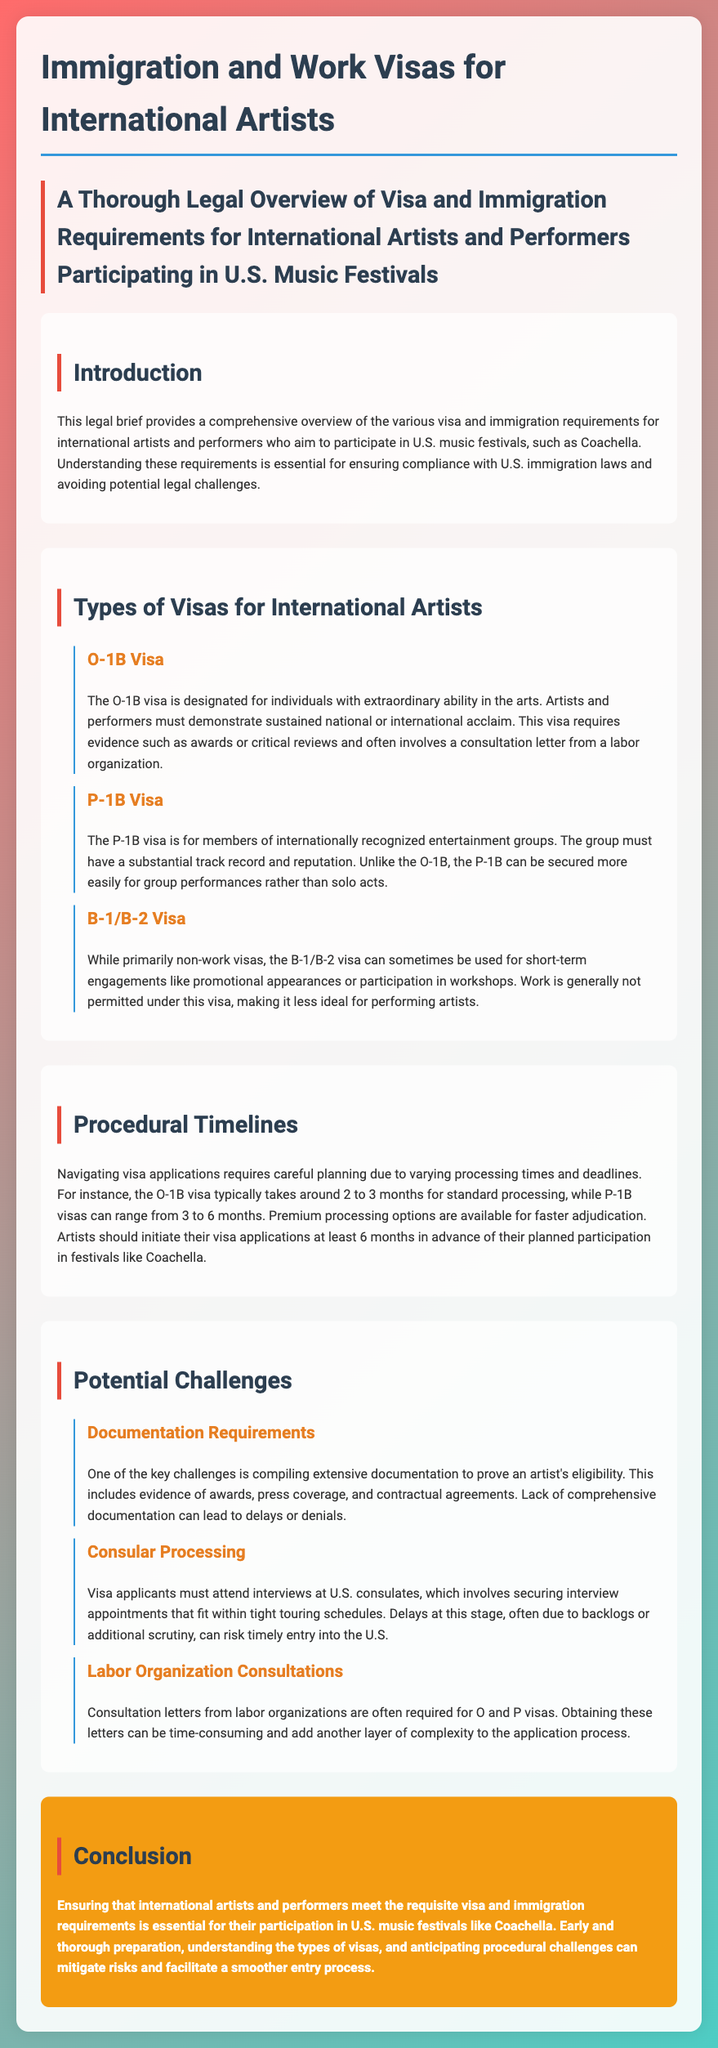What is the O-1B visa? The O-1B visa is designated for individuals with extraordinary ability in the arts.
Answer: extraordinary ability in the arts What is the typical processing time for an O-1B visa? The O-1B visa typically takes around 2 to 3 months for standard processing.
Answer: 2 to 3 months Which visa is for members of internationally recognized entertainment groups? The P-1B visa is for members of internationally recognized entertainment groups.
Answer: P-1B visa What is a key challenge mentioned regarding documentation for artists? A lack of comprehensive documentation can lead to delays or denials.
Answer: delays or denials How far in advance should artists initiate their visa applications? Artists should initiate their visa applications at least 6 months in advance.
Answer: 6 months What is often required for O and P visas? Consultation letters from labor organizations are often required for O and P visas.
Answer: Consultation letters What does the conclusion emphasize for international artists? Early and thorough preparation, understanding the types of visas, and anticipating procedural challenges.
Answer: preparation, understanding, anticipating challenges What is the main focus of this legal brief? The brief focuses on visa and immigration requirements for international artists and performers participating in U.S. music festivals.
Answer: visa and immigration requirements 